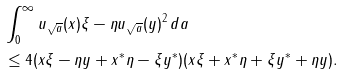<formula> <loc_0><loc_0><loc_500><loc_500>& \int _ { 0 } ^ { \infty } \| u _ { \sqrt { a } } ( x ) \xi - \eta u _ { \sqrt { a } } ( y ) \| ^ { 2 } \, d a \\ & \leq 4 ( \| x \xi - \eta y \| + \| x ^ { * } \eta - \xi y ^ { * } \| ) ( \| x \xi \| + \| x ^ { * } \eta \| + \| \xi y ^ { * } \| + \| \eta y \| ) .</formula> 